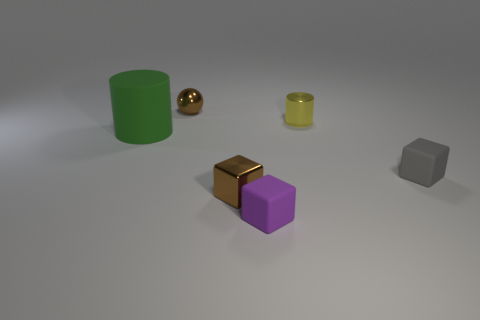Is the big cylinder made of the same material as the small gray block?
Provide a short and direct response. Yes. What is the color of the tiny thing that is in front of the brown metallic thing in front of the tiny object behind the tiny metallic cylinder?
Ensure brevity in your answer.  Purple. What is the shape of the yellow object?
Give a very brief answer. Cylinder. There is a large matte cylinder; is its color the same as the cylinder that is right of the tiny metal sphere?
Provide a succinct answer. No. Are there an equal number of green matte objects behind the yellow shiny cylinder and tiny cyan shiny blocks?
Provide a succinct answer. Yes. What number of balls are the same size as the yellow object?
Keep it short and to the point. 1. The metal object that is the same color as the small metallic sphere is what shape?
Your response must be concise. Cube. Are there any purple matte objects?
Your answer should be compact. Yes. There is a brown object that is on the right side of the metal sphere; is it the same shape as the small matte thing right of the yellow metallic cylinder?
Your response must be concise. Yes. What number of big objects are gray matte objects or yellow things?
Give a very brief answer. 0. 